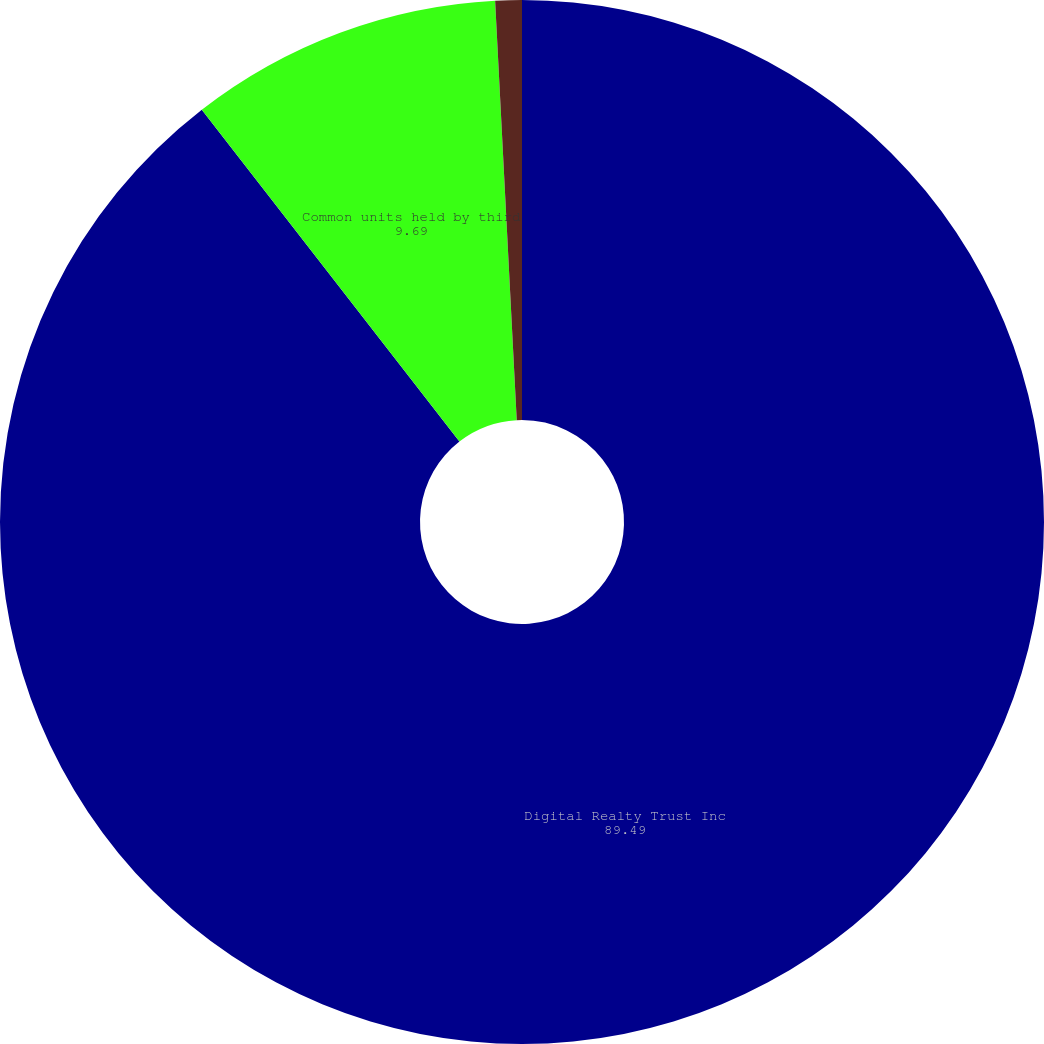<chart> <loc_0><loc_0><loc_500><loc_500><pie_chart><fcel>Digital Realty Trust Inc<fcel>Common units held by third<fcel>Incentive units held by<nl><fcel>89.49%<fcel>9.69%<fcel>0.82%<nl></chart> 